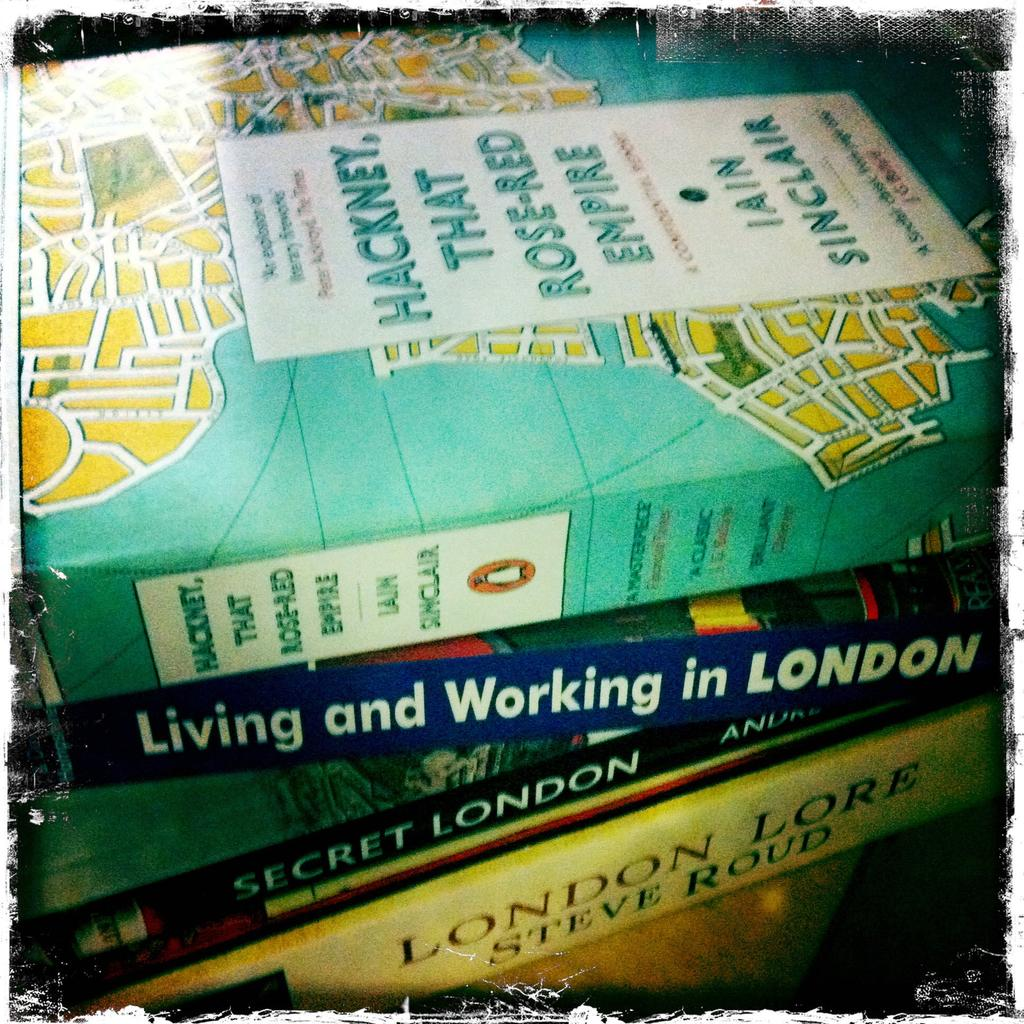<image>
Summarize the visual content of the image. Several travel books for London sit on a table including Living and Working in LONDON. 